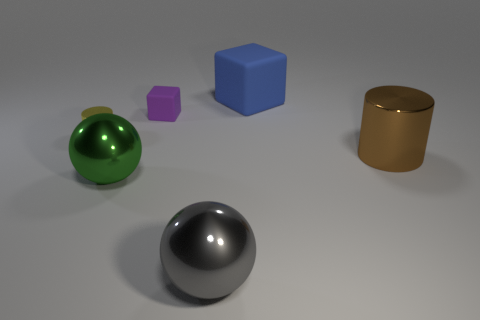Add 2 big gray metal objects. How many objects exist? 8 Subtract 0 purple balls. How many objects are left? 6 Subtract all spheres. How many objects are left? 4 Subtract 1 cylinders. How many cylinders are left? 1 Subtract all cyan cubes. Subtract all green cylinders. How many cubes are left? 2 Subtract all gray balls. How many red cylinders are left? 0 Subtract all large metallic things. Subtract all small yellow cylinders. How many objects are left? 2 Add 4 brown metal things. How many brown metal things are left? 5 Add 4 tiny cylinders. How many tiny cylinders exist? 5 Subtract all brown cylinders. How many cylinders are left? 1 